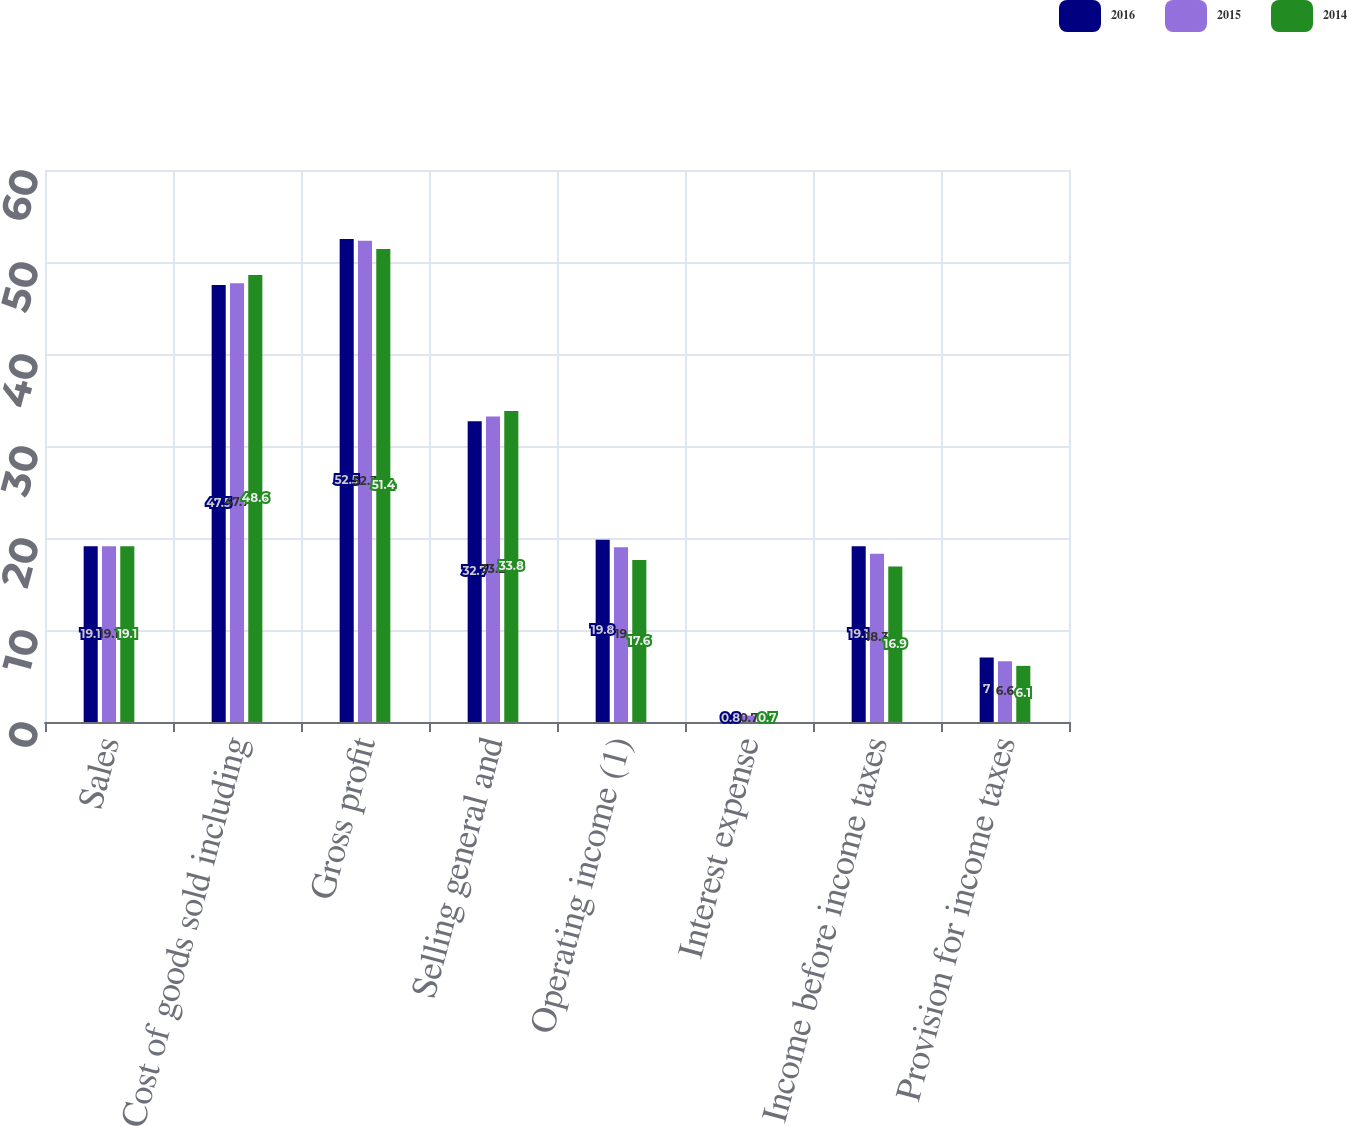Convert chart. <chart><loc_0><loc_0><loc_500><loc_500><stacked_bar_chart><ecel><fcel>Sales<fcel>Cost of goods sold including<fcel>Gross profit<fcel>Selling general and<fcel>Operating income (1)<fcel>Interest expense<fcel>Income before income taxes<fcel>Provision for income taxes<nl><fcel>2016<fcel>19.1<fcel>47.5<fcel>52.5<fcel>32.7<fcel>19.8<fcel>0.8<fcel>19.1<fcel>7<nl><fcel>2015<fcel>19.1<fcel>47.7<fcel>52.3<fcel>33.2<fcel>19<fcel>0.7<fcel>18.3<fcel>6.6<nl><fcel>2014<fcel>19.1<fcel>48.6<fcel>51.4<fcel>33.8<fcel>17.6<fcel>0.7<fcel>16.9<fcel>6.1<nl></chart> 